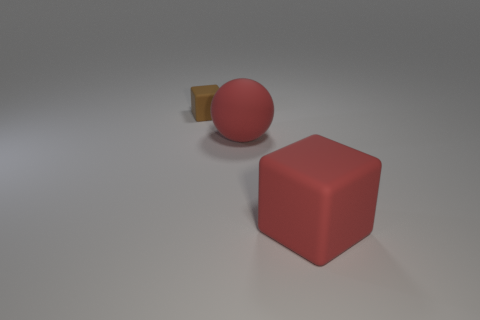Is there any other thing that is the same size as the red cube?
Keep it short and to the point. Yes. There is a tiny brown block; what number of big cubes are left of it?
Your answer should be compact. 0. Is the number of brown blocks that are to the right of the tiny matte thing the same as the number of blue spheres?
Offer a terse response. Yes. What number of objects are balls or purple objects?
Provide a succinct answer. 1. Is there anything else that has the same shape as the tiny thing?
Make the answer very short. Yes. What is the shape of the red thing on the left side of the block right of the tiny object?
Ensure brevity in your answer.  Sphere. The large object that is made of the same material as the red cube is what shape?
Ensure brevity in your answer.  Sphere. There is a block that is left of the cube in front of the small brown object; how big is it?
Provide a succinct answer. Small. The brown matte object has what shape?
Provide a short and direct response. Cube. How many small things are either metal spheres or red rubber cubes?
Provide a succinct answer. 0. 